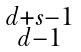<formula> <loc_0><loc_0><loc_500><loc_500>\begin{smallmatrix} d + s - 1 \\ d - 1 \\ \end{smallmatrix}</formula> 